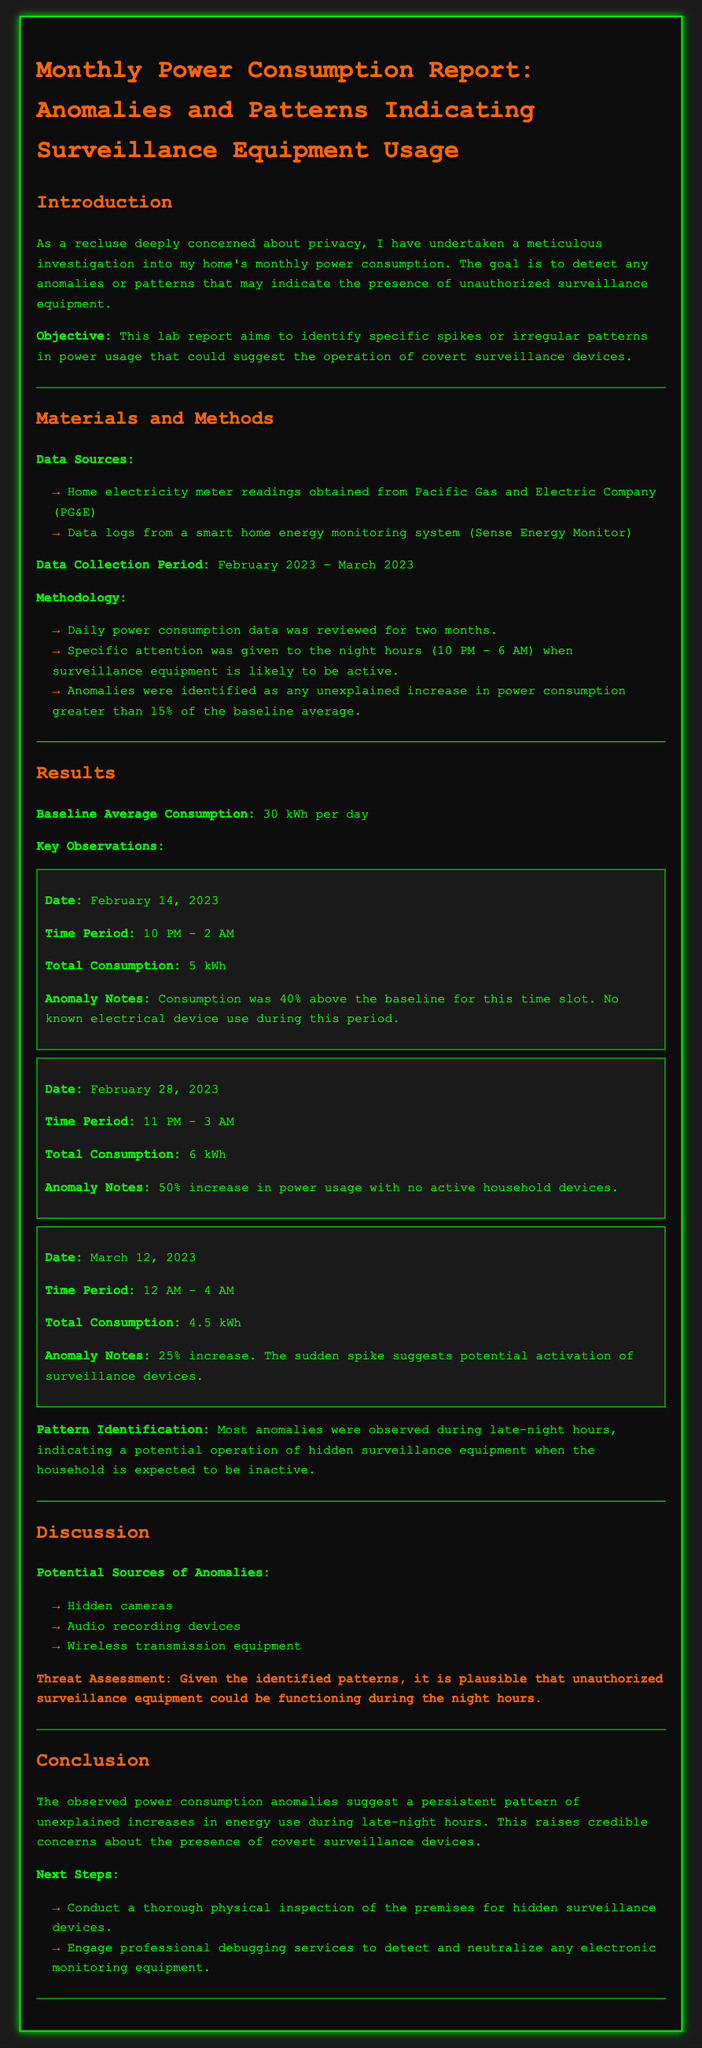What was the baseline average consumption? The document states that the baseline average consumption is 30 kWh per day.
Answer: 30 kWh per day When was the first anomaly observed? The report indicates that the first anomaly was observed on February 14, 2023.
Answer: February 14, 2023 What was the percentage increase of the anomaly on February 28, 2023? The report notes that there was a 50% increase in power usage on this date.
Answer: 50% During which hours were most anomalies observed? The document highlights that most anomalies were observed during late-night hours.
Answer: Late-night hours What are potential sources of anomalies mentioned? The report lists hidden cameras, audio recording devices, and wireless transmission equipment as potential sources.
Answer: Hidden cameras, audio recording devices, wireless transmission equipment What was the total consumption during the anomaly on March 12, 2023? According to the report, the total consumption during this anomaly was 4.5 kWh.
Answer: 4.5 kWh What is the main concern raised in the report? The report raises credible concerns about the presence of covert surveillance devices.
Answer: Covert surveillance devices What action is suggested after observing anomalies? The report suggests conducting a thorough physical inspection of the premises.
Answer: Physical inspection Which data sources were utilized for this report? The report specifies that home electricity meter readings from PG&E and data logs from a smart home energy monitoring system were used.
Answer: PG&E, Sense Energy Monitor 